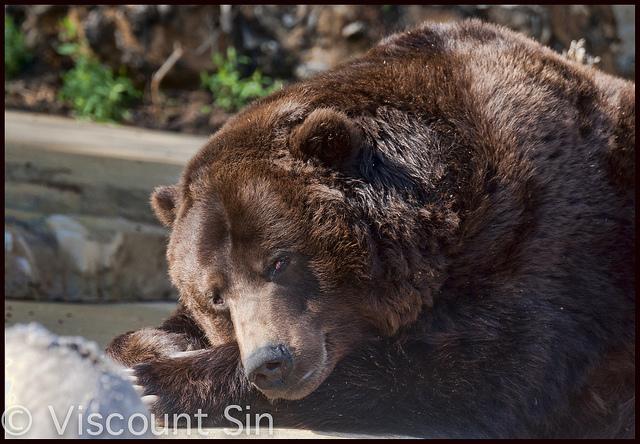Is the bear asleep?
Write a very short answer. No. What kind of bear is this?
Answer briefly. Brown. How many bears?
Write a very short answer. 1. How many of these animals have paws?
Short answer required. 1. What color is the bear's fur?
Short answer required. Brown. Is there a bear cub nearby?
Concise answer only. No. What color is the animal?
Keep it brief. Brown. Are these animals asleep or eating?
Short answer required. Asleep. Is this photo real?
Quick response, please. Yes. How many bears do you see?
Keep it brief. 1. What is this animal?
Write a very short answer. Bear. 